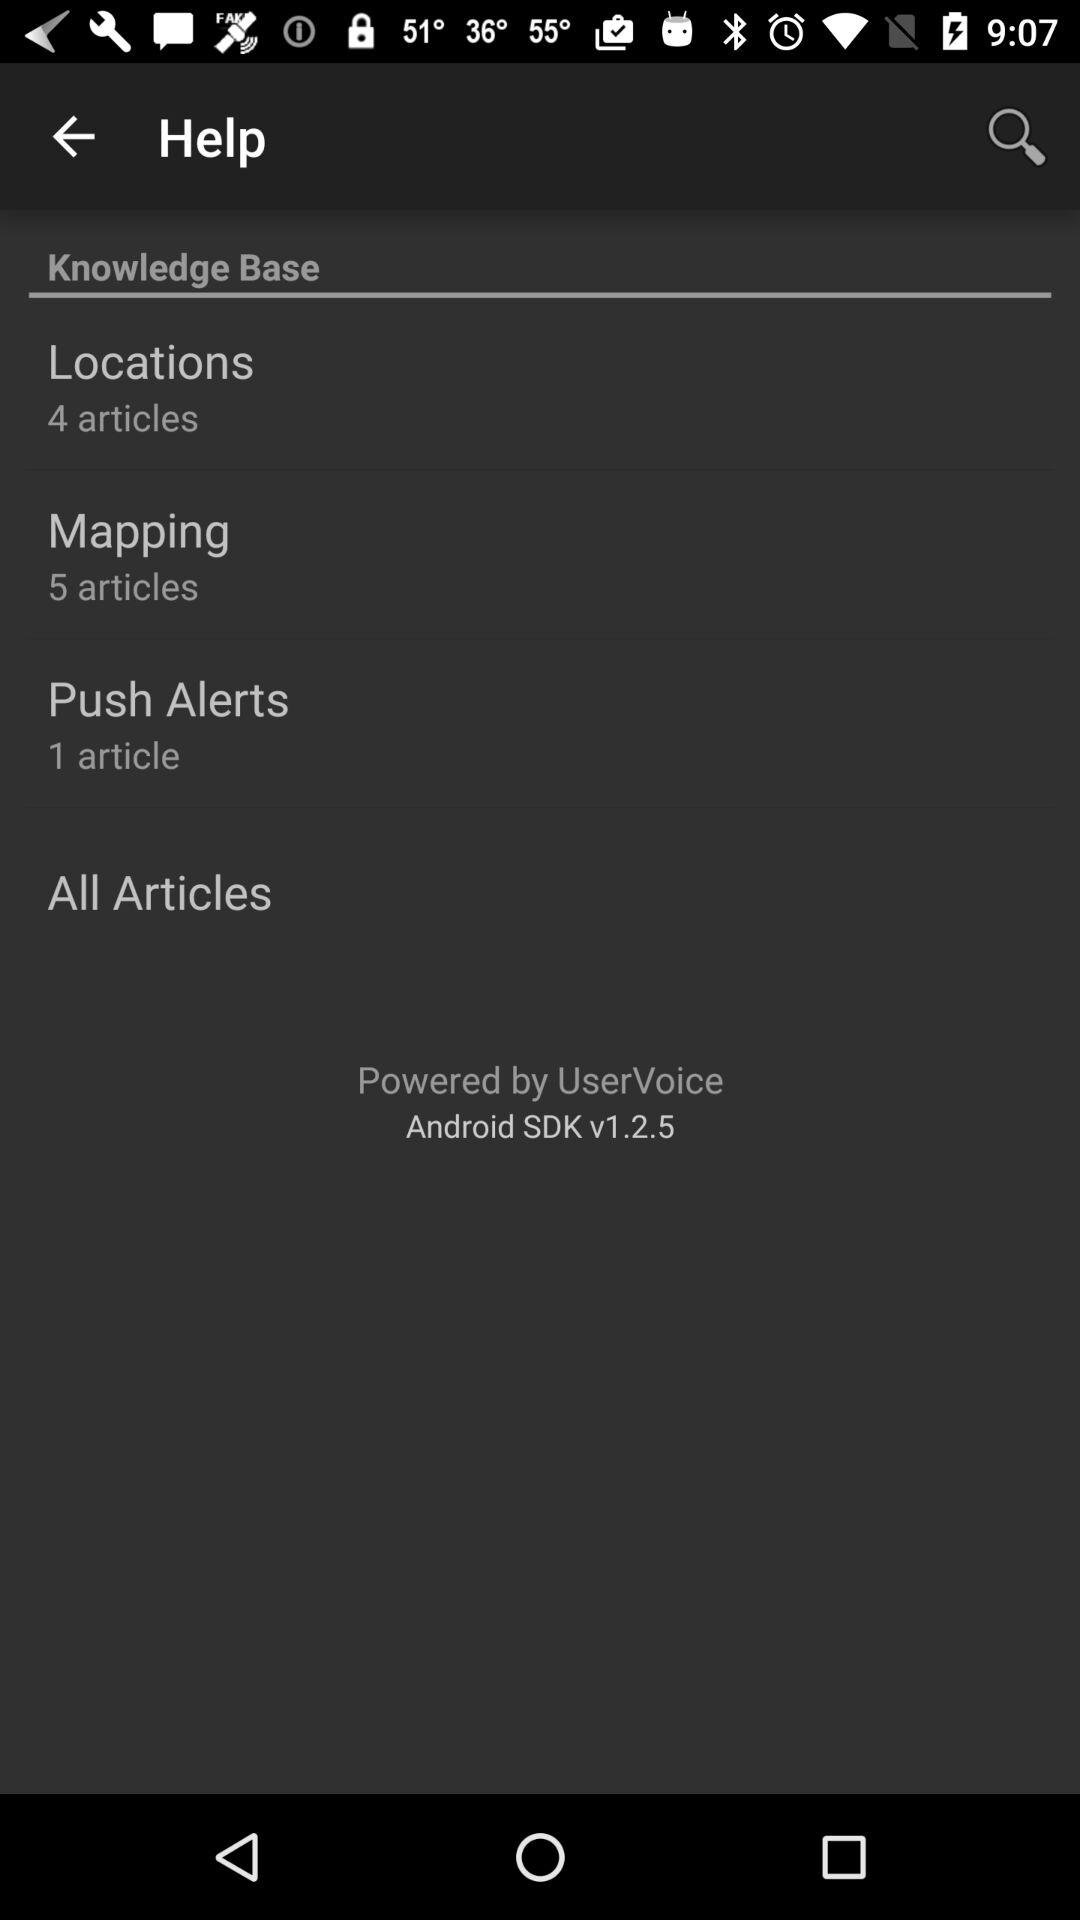How many articles are there in "Push Alerts"? There is 1 article in "Push Alerts". 